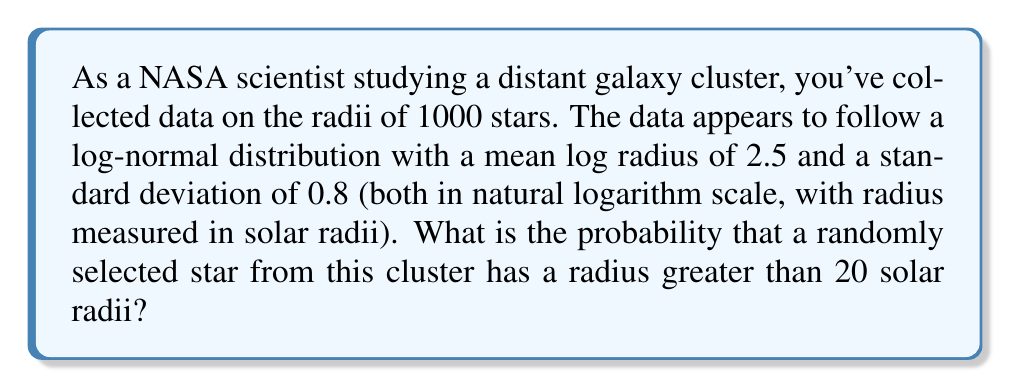Solve this math problem. To solve this problem, we need to use the properties of the log-normal distribution and the standard normal distribution.

1) In a log-normal distribution, if $X$ is log-normally distributed, then $Y = \ln(X)$ is normally distributed.

2) We're given that $Y = \ln(X)$ has a mean $\mu = 2.5$ and standard deviation $\sigma = 0.8$.

3) We want to find $P(X > 20)$, which is equivalent to $P(\ln(X) > \ln(20))$.

4) Calculate $\ln(20) = 2.9957$.

5) To use the standard normal distribution, we need to standardize our value:

   $$Z = \frac{\ln(20) - \mu}{\sigma} = \frac{2.9957 - 2.5}{0.8} = 0.6196$$

6) We want $P(Y > \ln(20))$, which is equivalent to $P(Z > 0.6196)$.

7) Using a standard normal table or calculator, we can find that $P(Z > 0.6196) = 1 - P(Z < 0.6196) = 1 - 0.7324 = 0.2676$.

Therefore, the probability that a randomly selected star from this cluster has a radius greater than 20 solar radii is approximately 0.2676 or 26.76%.
Answer: 0.2676 or 26.76% 